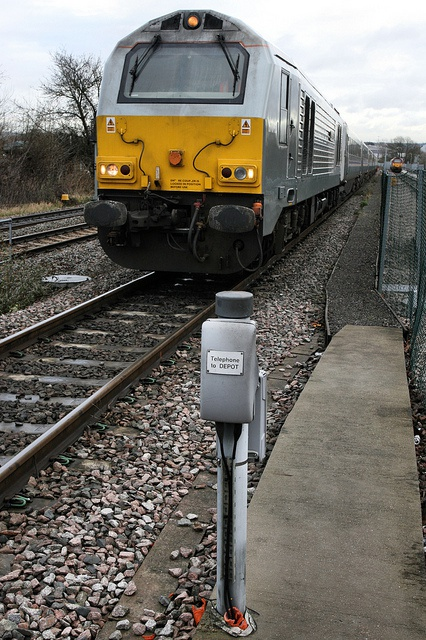Describe the objects in this image and their specific colors. I can see a train in white, black, gray, darkgray, and olive tones in this image. 